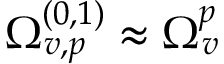Convert formula to latex. <formula><loc_0><loc_0><loc_500><loc_500>\Omega _ { v , p } ^ { ( 0 , 1 ) } \approx \Omega _ { v } ^ { p }</formula> 